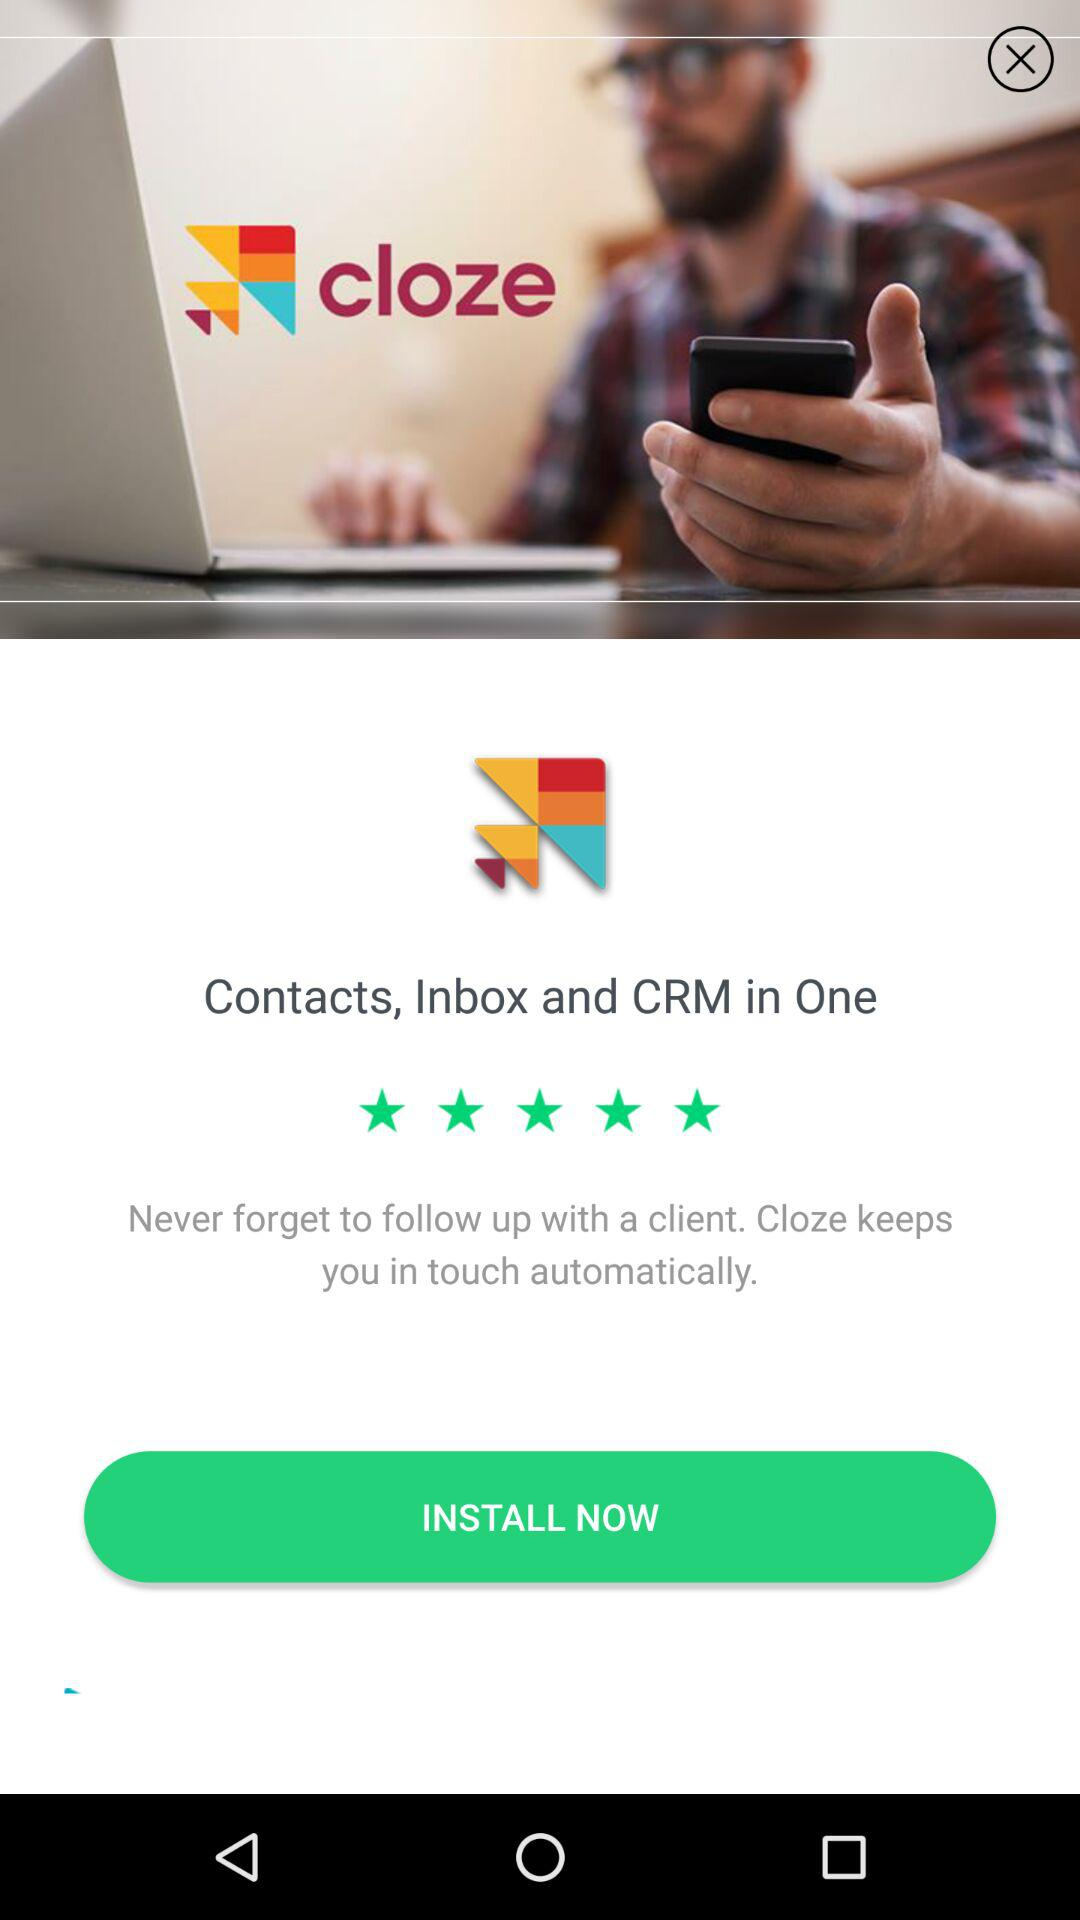What is the rating of cloze? The rating is 5 stars. 